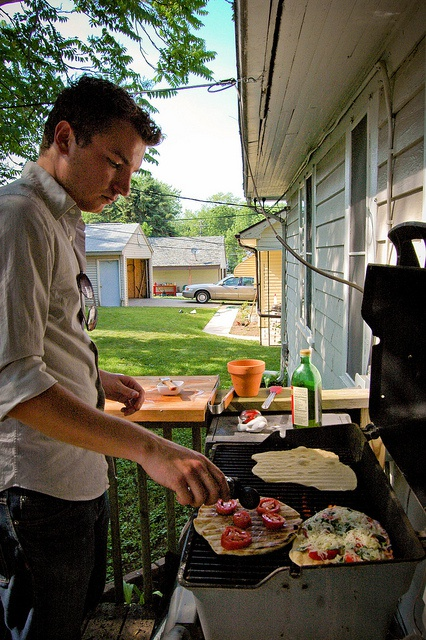Describe the objects in this image and their specific colors. I can see people in black, maroon, and gray tones, pizza in black, maroon, gray, and olive tones, pizza in black, tan, gray, and olive tones, pizza in black, tan, and gray tones, and bottle in black, tan, and darkgreen tones in this image. 